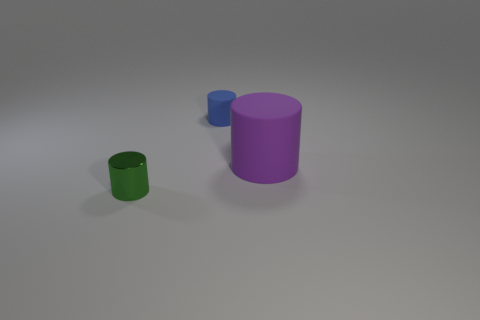Add 1 green shiny cylinders. How many objects exist? 4 Add 3 green metal cylinders. How many green metal cylinders exist? 4 Subtract 0 red cubes. How many objects are left? 3 Subtract all purple metallic cubes. Subtract all tiny blue matte things. How many objects are left? 2 Add 2 small blue rubber cylinders. How many small blue rubber cylinders are left? 3 